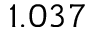Convert formula to latex. <formula><loc_0><loc_0><loc_500><loc_500>1 . 0 3 7</formula> 